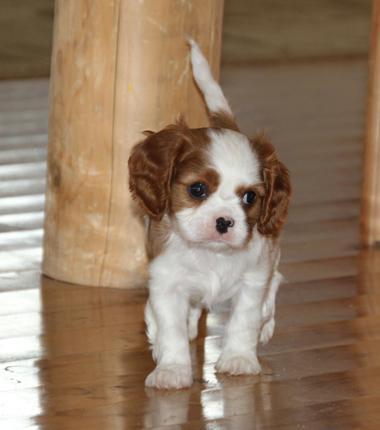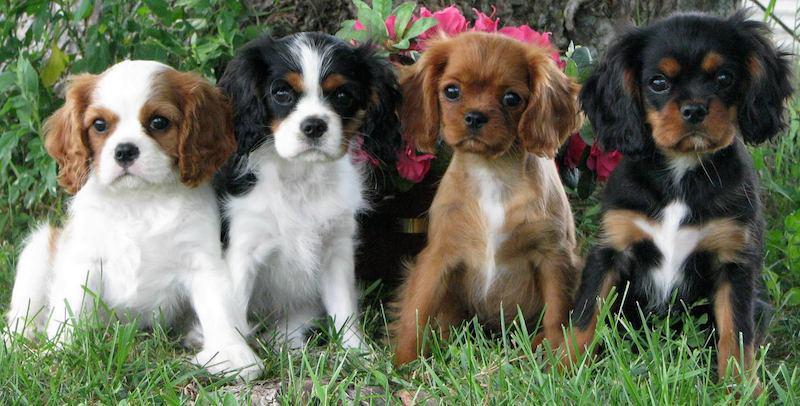The first image is the image on the left, the second image is the image on the right. For the images displayed, is the sentence "An image shows a horizontal row of four different-colored dogs sitting on the grass." factually correct? Answer yes or no. Yes. 